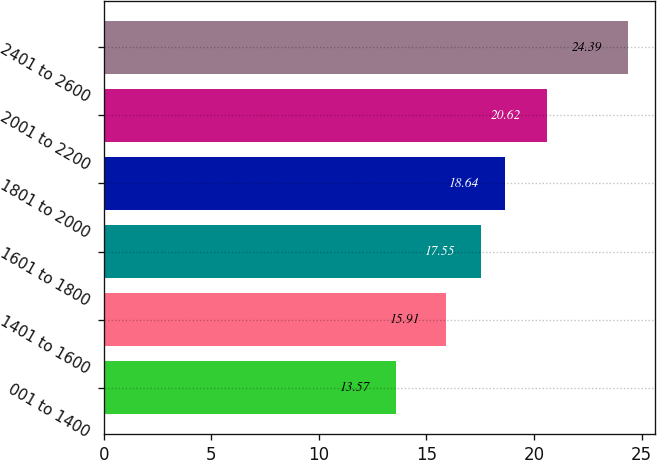<chart> <loc_0><loc_0><loc_500><loc_500><bar_chart><fcel>001 to 1400<fcel>1401 to 1600<fcel>1601 to 1800<fcel>1801 to 2000<fcel>2001 to 2200<fcel>2401 to 2600<nl><fcel>13.57<fcel>15.91<fcel>17.55<fcel>18.64<fcel>20.62<fcel>24.39<nl></chart> 